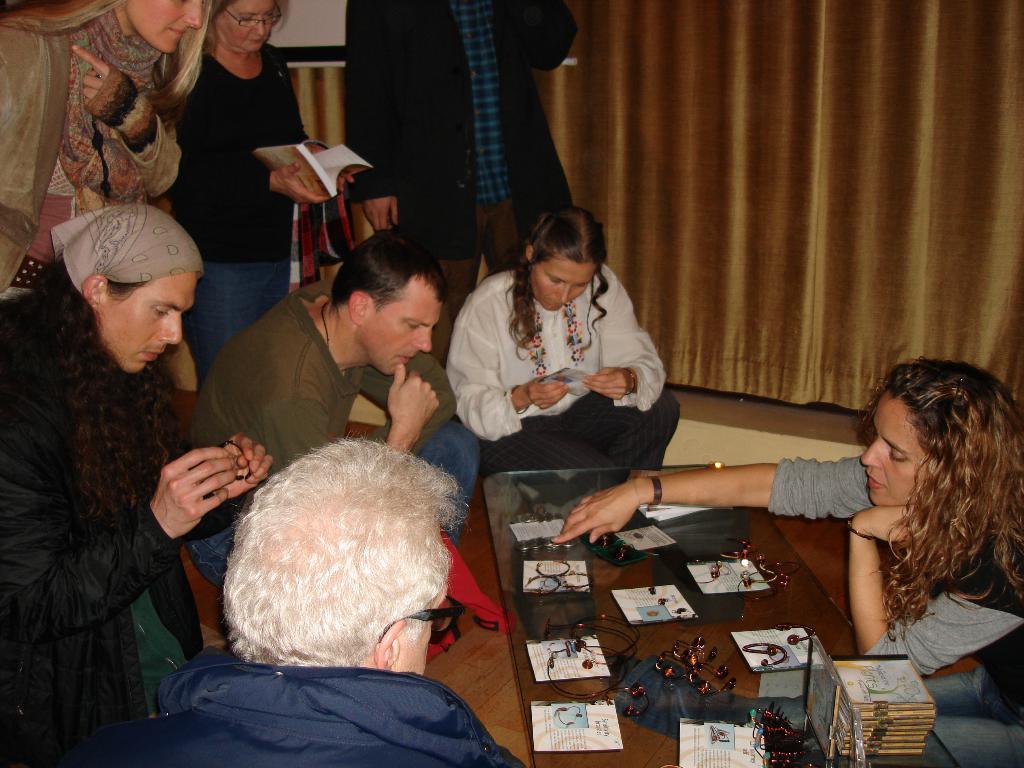In one or two sentences, can you explain what this image depicts? In this image i can see few people sitting and few people standing. In the background i can see a golden color curtain. 